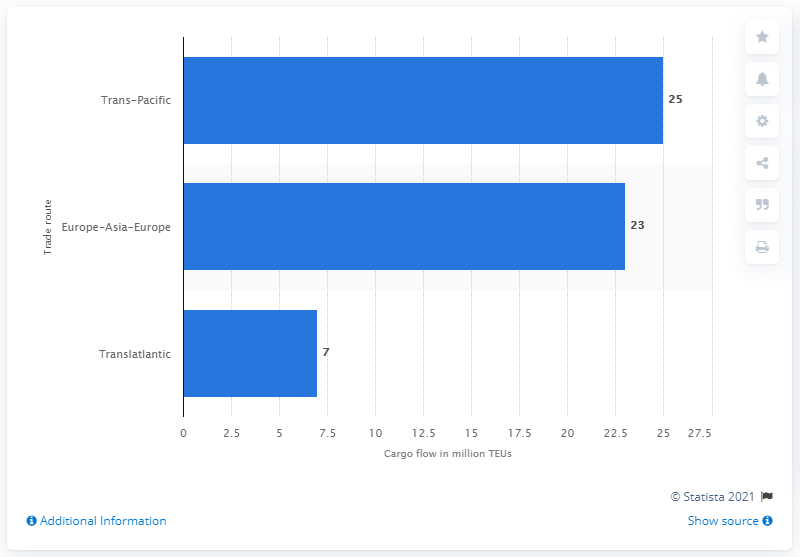Mention a couple of crucial points in this snapshot. In 2020, it is expected that approximately 25 million twenty-foot equivalent units (TEU) of cargo will be transported across the Pacific Ocean. 